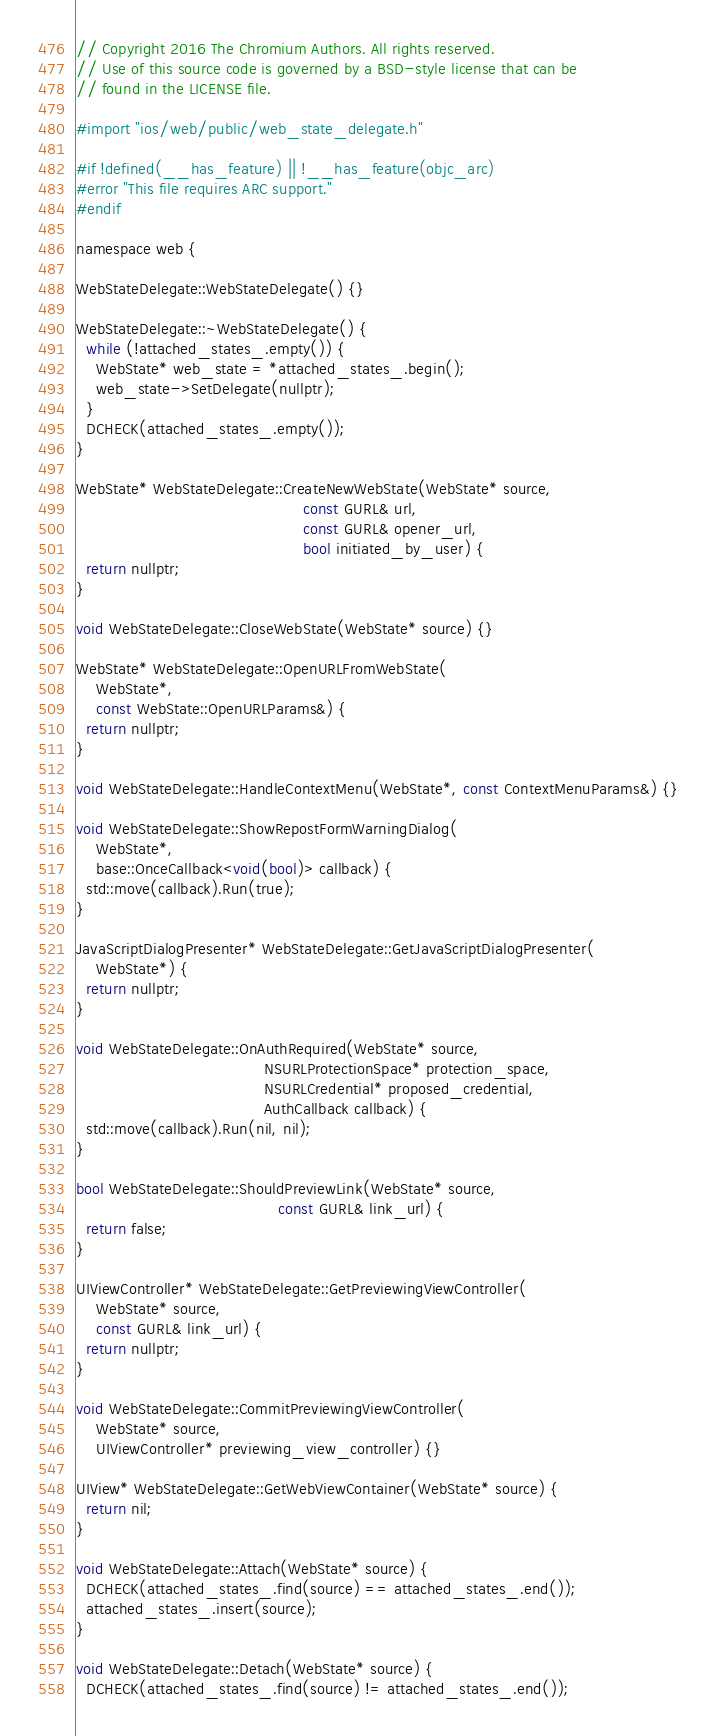Convert code to text. <code><loc_0><loc_0><loc_500><loc_500><_ObjectiveC_>// Copyright 2016 The Chromium Authors. All rights reserved.
// Use of this source code is governed by a BSD-style license that can be
// found in the LICENSE file.

#import "ios/web/public/web_state_delegate.h"

#if !defined(__has_feature) || !__has_feature(objc_arc)
#error "This file requires ARC support."
#endif

namespace web {

WebStateDelegate::WebStateDelegate() {}

WebStateDelegate::~WebStateDelegate() {
  while (!attached_states_.empty()) {
    WebState* web_state = *attached_states_.begin();
    web_state->SetDelegate(nullptr);
  }
  DCHECK(attached_states_.empty());
}

WebState* WebStateDelegate::CreateNewWebState(WebState* source,
                                              const GURL& url,
                                              const GURL& opener_url,
                                              bool initiated_by_user) {
  return nullptr;
}

void WebStateDelegate::CloseWebState(WebState* source) {}

WebState* WebStateDelegate::OpenURLFromWebState(
    WebState*,
    const WebState::OpenURLParams&) {
  return nullptr;
}

void WebStateDelegate::HandleContextMenu(WebState*, const ContextMenuParams&) {}

void WebStateDelegate::ShowRepostFormWarningDialog(
    WebState*,
    base::OnceCallback<void(bool)> callback) {
  std::move(callback).Run(true);
}

JavaScriptDialogPresenter* WebStateDelegate::GetJavaScriptDialogPresenter(
    WebState*) {
  return nullptr;
}

void WebStateDelegate::OnAuthRequired(WebState* source,
                                      NSURLProtectionSpace* protection_space,
                                      NSURLCredential* proposed_credential,
                                      AuthCallback callback) {
  std::move(callback).Run(nil, nil);
}

bool WebStateDelegate::ShouldPreviewLink(WebState* source,
                                         const GURL& link_url) {
  return false;
}

UIViewController* WebStateDelegate::GetPreviewingViewController(
    WebState* source,
    const GURL& link_url) {
  return nullptr;
}

void WebStateDelegate::CommitPreviewingViewController(
    WebState* source,
    UIViewController* previewing_view_controller) {}

UIView* WebStateDelegate::GetWebViewContainer(WebState* source) {
  return nil;
}

void WebStateDelegate::Attach(WebState* source) {
  DCHECK(attached_states_.find(source) == attached_states_.end());
  attached_states_.insert(source);
}

void WebStateDelegate::Detach(WebState* source) {
  DCHECK(attached_states_.find(source) != attached_states_.end());</code> 